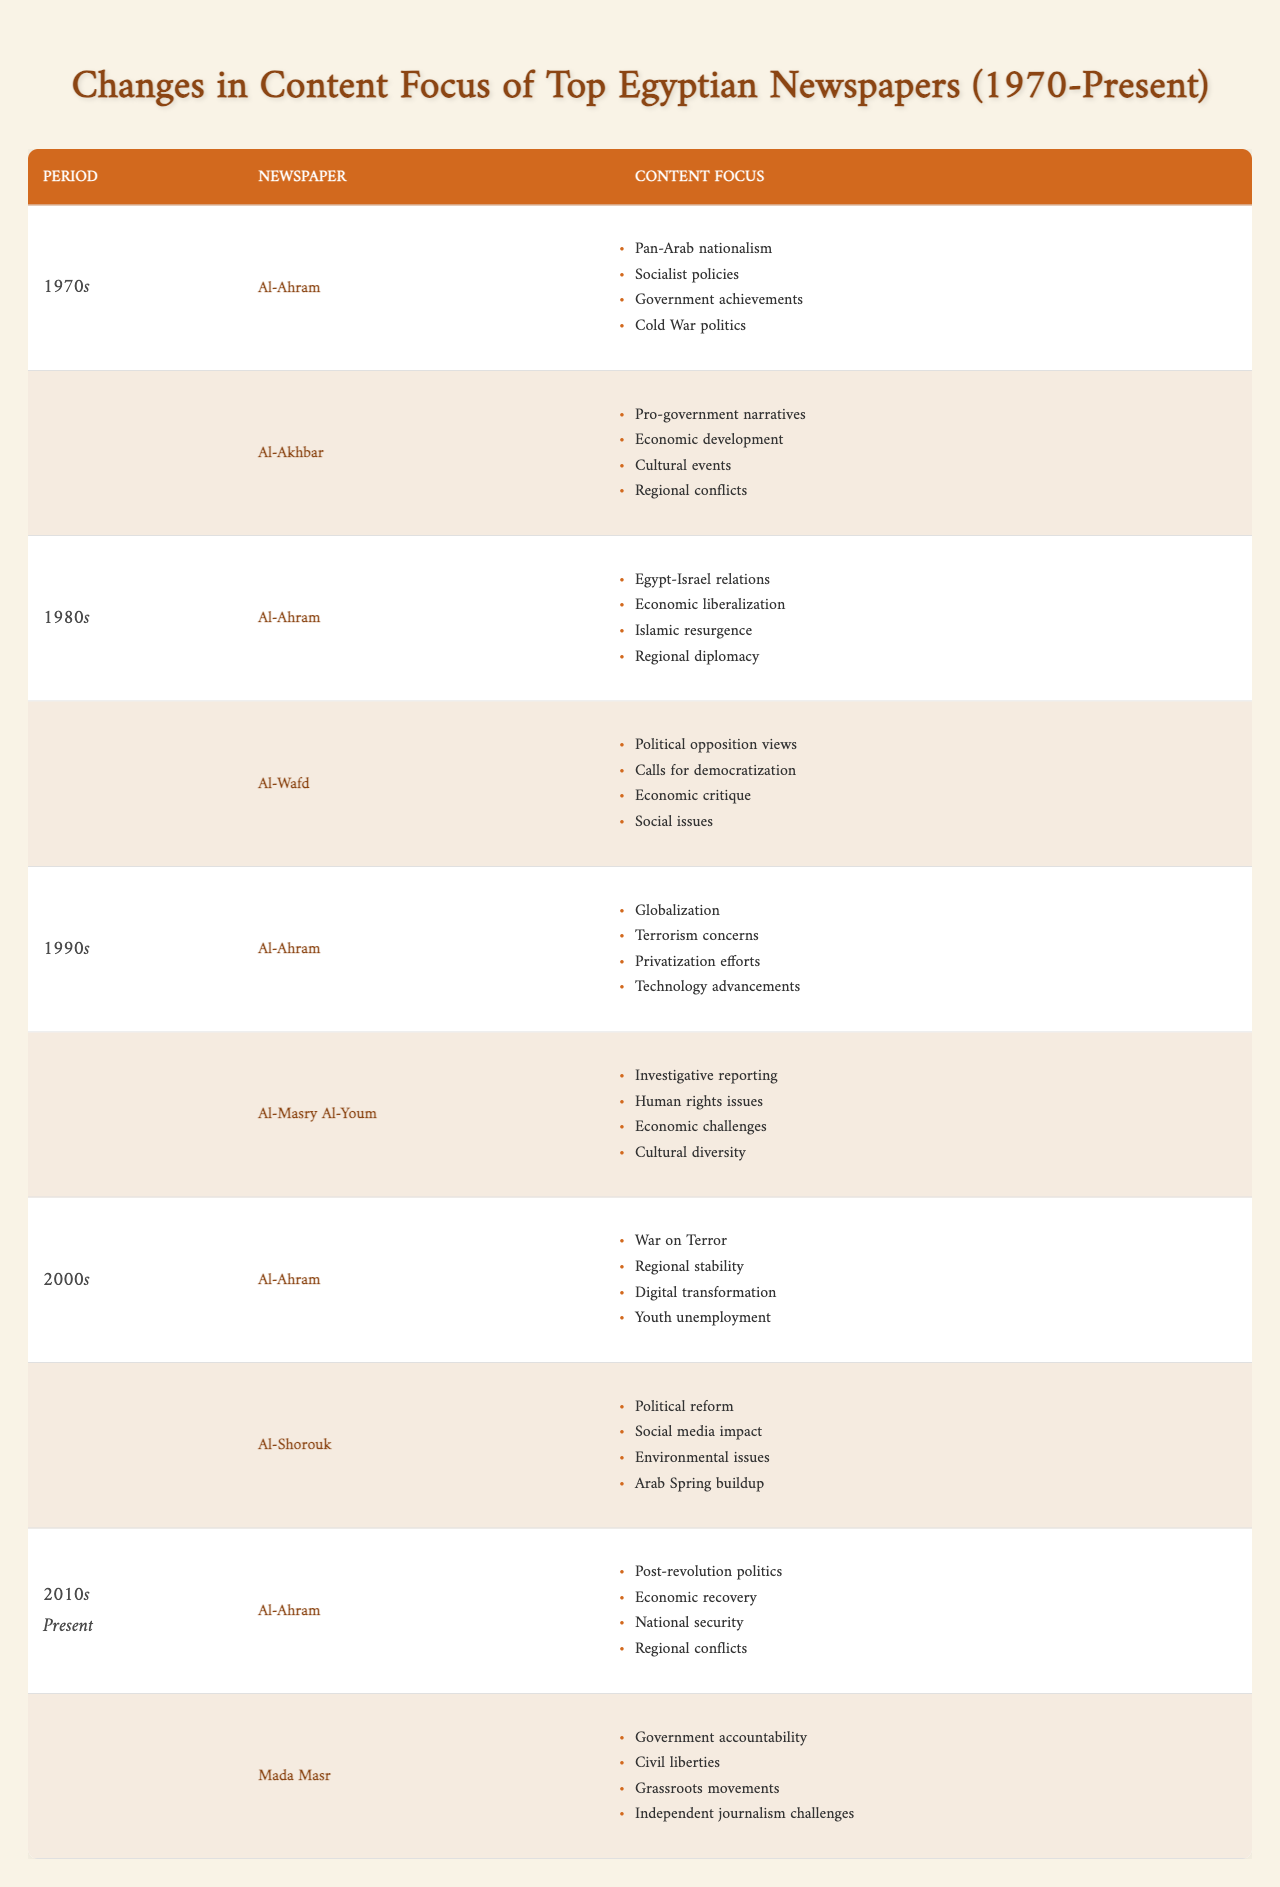What were the main content focuses of Al-Ahram in the 1980s? According to the table, Al-Ahram's focuses in the 1980s included Egypt-Israel relations, economic liberalization, Islamic resurgence, and regional diplomacy.
Answer: Egypt-Israel relations, economic liberalization, Islamic resurgence, regional diplomacy Which new newspaper emerged in the 1990s with a focus on investigative reporting? The table lists Al-Masry Al-Youm as the new newspaper that emerged in the 1990s, focusing on investigative reporting, human rights issues, economic challenges, and cultural diversity.
Answer: Al-Masry Al-Youm Did Al-Wafd have any focus on economic critique during the 1980s? Yes, the table indicates that Al-Wafd's focuses in the 1980s included political opposition views, calls for democratization, economic critique, and social issues.
Answer: Yes How many distinct content focuses did Al-Ahram have across the 1970s and 1980s? In the 1970s, Al-Ahram focused on four areas, while in the 1980s, it also focused on four areas. So the total distinct focuses combining both decades is 4 + 4 = 8, without overlapping ones. These are: Pan-Arab nationalism, socialist policies, government achievements, Cold War politics, Egypt-Israel relations, economic liberalization, Islamic resurgence, and regional diplomacy.
Answer: 8 What type of issues did Mada Masr focus on from 2010s to present? The focuses of Mada Masr from 2010s to present include government accountability, civil liberties, grassroots movements, and independent journalism challenges.
Answer: Government accountability, civil liberties, grassroots movements, independent journalism challenges What was the shift in content focus for Al-Ahram from the 2000s to the 2010s? In the 2000s, Al-Ahram's focus was on the War on Terror, regional stability, digital transformation, and youth unemployment. In the 2010s, the focus shifted to post-revolution politics, economic recovery, national security, and regional conflicts. This shows a shift from a security-centric focus towards political and economic themes post-revolution.
Answer: Shifted to post-revolution politics, economic recovery, national security, regional conflicts Did Al-Shorouk discuss environmental issues in its content focus of the 2000s? Yes, according to the data, Al-Shorouk's focus in the 2000s included political reform, social media impact, environmental issues, and the buildup to the Arab Spring.
Answer: Yes How do the content focuses of the 1990s compare to those of the 2010s for Al-Ahram? In the 1990s, Al-Ahram focused on globalization, terrorism concerns, privatization efforts, and technology advancements. In the 2010s, its focuses were on post-revolution politics, economic recovery, national security, and regional conflicts, indicating a transition towards more immediate political concerns compared to broader issues in the 1990s.
Answer: Transition towards immediate political concerns Which decade saw a rise in the focus on government accountability and civil liberties? The 2010s saw a rise in the focus on government accountability and civil liberties, especially with the emergence of Mada Masr, which specifically highlighted these themes in its content focus.
Answer: 2010s 